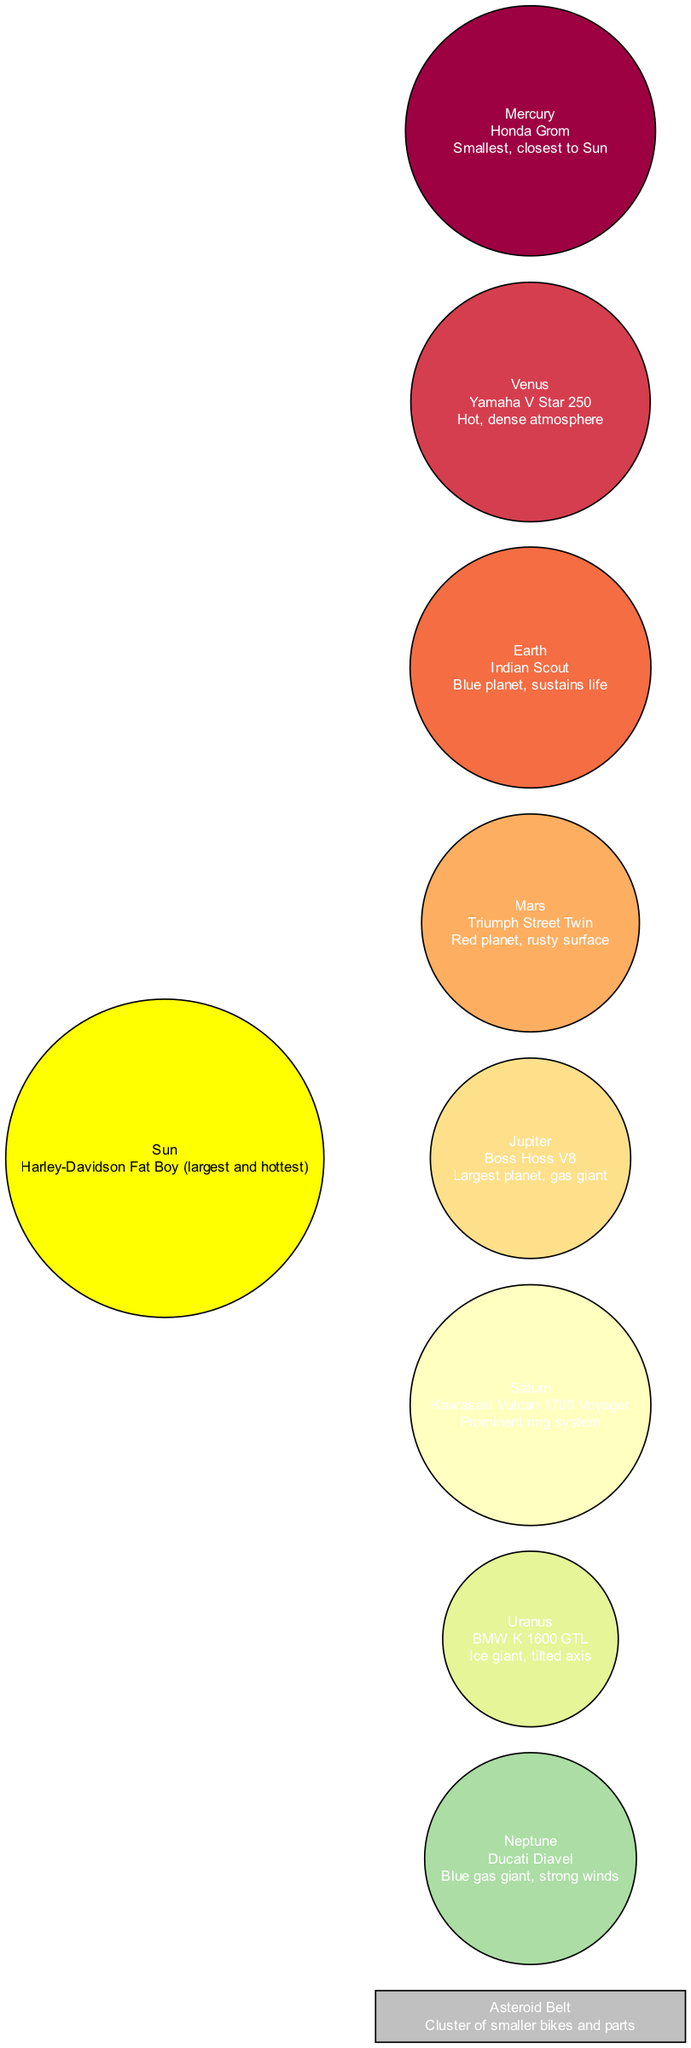What is the name of the motorcycle representing Saturn? According to the diagram, Saturn is represented by the Kawasaki Vulcan 1700 Voyager. This information can be found by locating the node for Saturn in the diagram and referencing its description.
Answer: Kawasaki Vulcan 1700 Voyager How many planets are displayed in the diagram? The diagram lists a total of eight planets. By counting the individual planet nodes mentioned in the data, we can confirm this total.
Answer: 8 Which planet is illustrated as the smallest? In the diagram, Mercury is depicted as the smallest planet and is characterized by being the closest to the Sun. This detail can be verified by looking at the description associated with Mercury’s node.
Answer: Mercury What is the description of the Sun in the diagram? The Sun is described as the Harley-Davidson Fat Boy, noted for being the largest and hottest. This information is found directly in the corresponding node for the Sun.
Answer: Harley-Davidson Fat Boy (largest and hottest) Which planet features a prominent ring system? Saturn is highlighted in the diagram as having a prominent ring system, which can be deduced by examining the features listed in its node description.
Answer: Saturn Which motorcycle is associated with the blue gas giant? Neptune is the planet that corresponds to the Ducati Diavel, which is noted as the blue gas giant. This can be confirmed by referencing the details listed under Neptune's node in the diagram.
Answer: Ducati Diavel What type of bikes are included in the Asteroid Belt? The Asteroid Belt is represented as a cluster of smaller bikes and parts. This information can be found in the description assigned to the Asteroid Belt node.
Answer: Smaller bikes and parts Which motorcycle represents the Earth? The Indian Scout represents Earth in the diagram, and this information is directly found within Earth’s respective node.
Answer: Indian Scout What is unique about Uranus in the diagram? Uranus is characterized as an ice giant with a tilted axis, which can be confirmed by reading the details associated with Uranus's node in the diagram.
Answer: Ice giant, tilted axis 